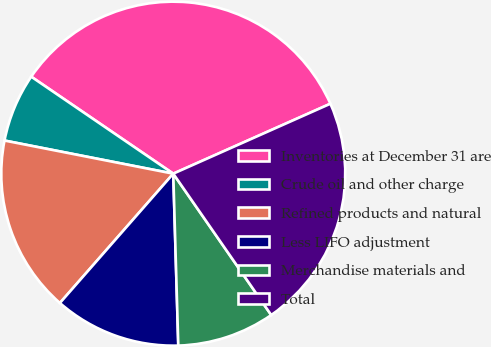<chart> <loc_0><loc_0><loc_500><loc_500><pie_chart><fcel>Inventories at December 31 are<fcel>Crude oil and other charge<fcel>Refined products and natural<fcel>Less LIFO adjustment<fcel>Merchandise materials and<fcel>Total<nl><fcel>33.8%<fcel>6.45%<fcel>16.63%<fcel>11.92%<fcel>9.18%<fcel>22.02%<nl></chart> 